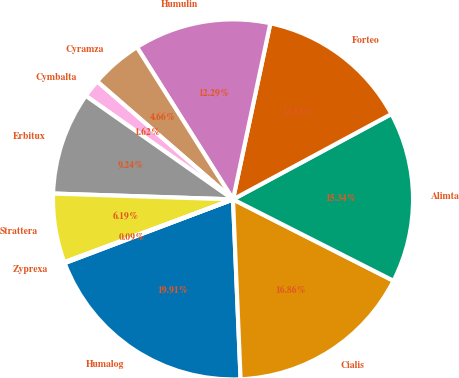Convert chart. <chart><loc_0><loc_0><loc_500><loc_500><pie_chart><fcel>Humalog<fcel>Cialis<fcel>Alimta<fcel>Forteo<fcel>Humulin<fcel>Cyramza<fcel>Cymbalta<fcel>Erbitux<fcel>Strattera<fcel>Zyprexa<nl><fcel>19.91%<fcel>16.86%<fcel>15.34%<fcel>13.81%<fcel>12.29%<fcel>4.66%<fcel>1.62%<fcel>9.24%<fcel>6.19%<fcel>0.09%<nl></chart> 